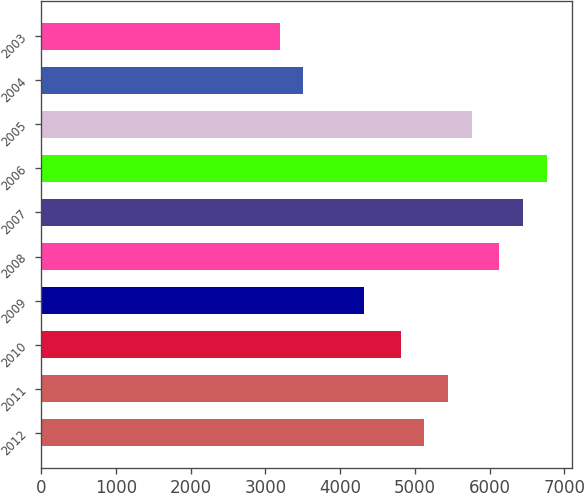Convert chart to OTSL. <chart><loc_0><loc_0><loc_500><loc_500><bar_chart><fcel>2012<fcel>2011<fcel>2010<fcel>2009<fcel>2008<fcel>2007<fcel>2006<fcel>2005<fcel>2004<fcel>2003<nl><fcel>5125.7<fcel>5443.4<fcel>4808<fcel>4320<fcel>6127<fcel>6444.7<fcel>6762.4<fcel>5761.1<fcel>3506.7<fcel>3189<nl></chart> 